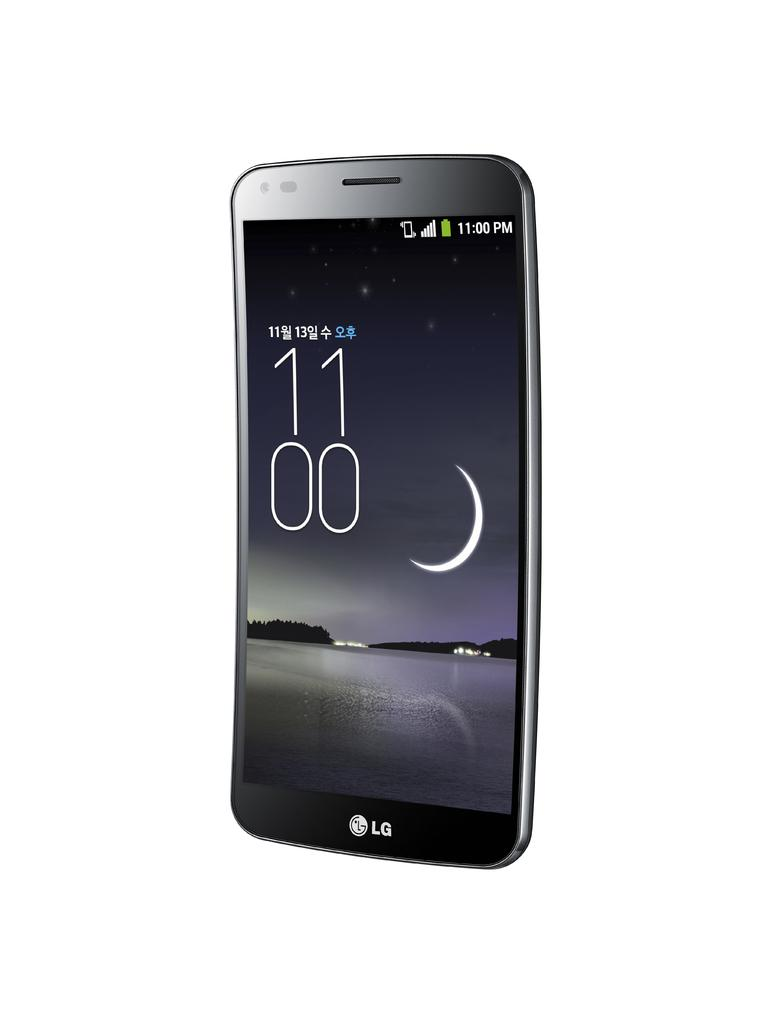Provide a one-sentence caption for the provided image. An LG phone displaying the time 11:00 p.m. and showing the image of a crescent moon. 